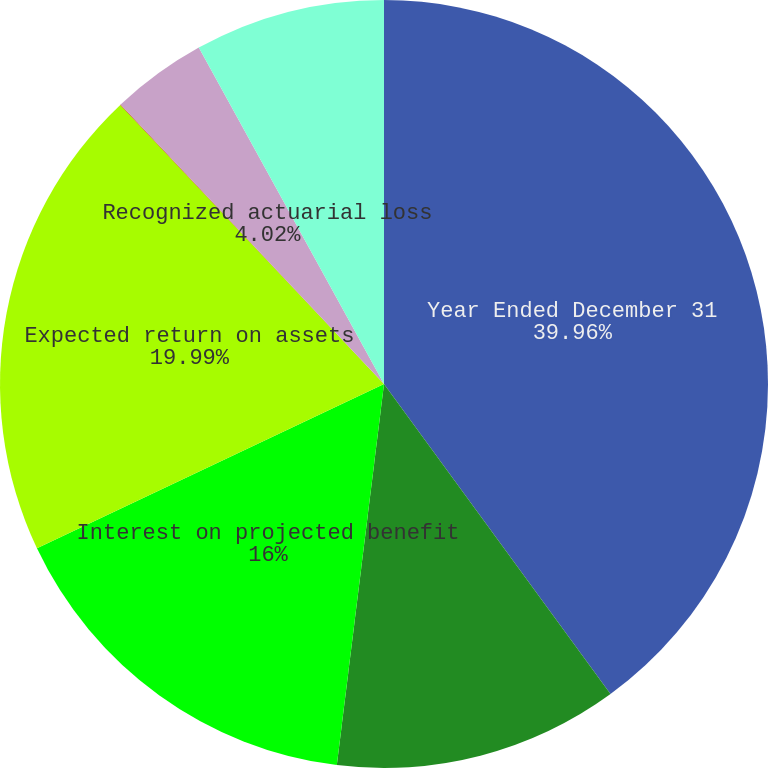<chart> <loc_0><loc_0><loc_500><loc_500><pie_chart><fcel>Year Ended December 31<fcel>Service cost<fcel>Interest on projected benefit<fcel>Expected return on assets<fcel>Amortization of prior service<fcel>Recognized actuarial loss<fcel>Net pension expense<nl><fcel>39.96%<fcel>12.0%<fcel>16.0%<fcel>19.99%<fcel>0.02%<fcel>4.02%<fcel>8.01%<nl></chart> 